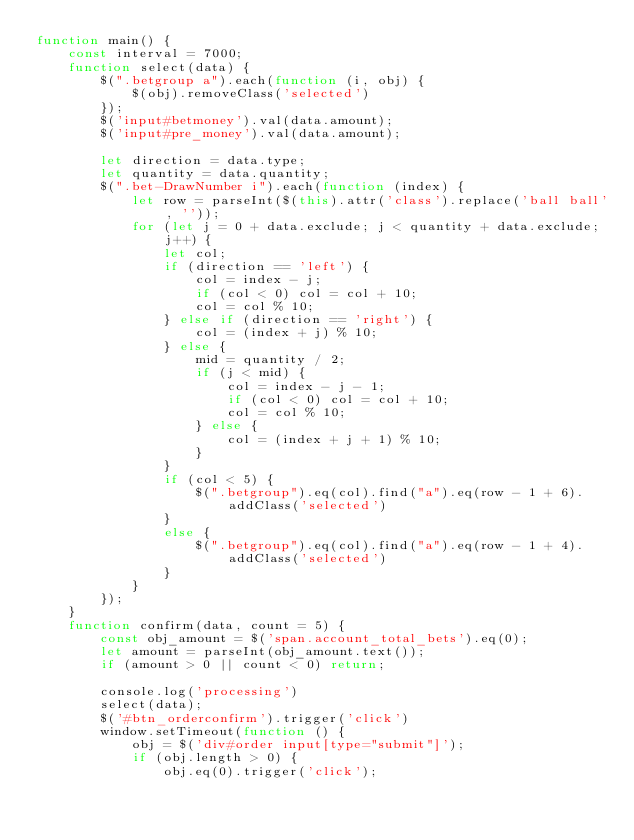Convert code to text. <code><loc_0><loc_0><loc_500><loc_500><_JavaScript_>function main() {
    const interval = 7000;
    function select(data) {
        $(".betgroup a").each(function (i, obj) {
            $(obj).removeClass('selected')
        });
        $('input#betmoney').val(data.amount);
        $('input#pre_money').val(data.amount);

        let direction = data.type;
        let quantity = data.quantity;
        $(".bet-DrawNumber i").each(function (index) {
            let row = parseInt($(this).attr('class').replace('ball ball', ''));
            for (let j = 0 + data.exclude; j < quantity + data.exclude; j++) {
                let col;
                if (direction == 'left') {
                    col = index - j;
                    if (col < 0) col = col + 10;
                    col = col % 10;
                } else if (direction == 'right') {
                    col = (index + j) % 10;
                } else {
                    mid = quantity / 2;
                    if (j < mid) {
                        col = index - j - 1;
                        if (col < 0) col = col + 10;
                        col = col % 10;
                    } else {
                        col = (index + j + 1) % 10;
                    }
                }
                if (col < 5) {
                    $(".betgroup").eq(col).find("a").eq(row - 1 + 6).addClass('selected')
                }
                else {
                    $(".betgroup").eq(col).find("a").eq(row - 1 + 4).addClass('selected')
                }
            }
        });
    }
    function confirm(data, count = 5) {
        const obj_amount = $('span.account_total_bets').eq(0);
        let amount = parseInt(obj_amount.text());
        if (amount > 0 || count < 0) return;

        console.log('processing')
        select(data);
        $('#btn_orderconfirm').trigger('click')
        window.setTimeout(function () {
            obj = $('div#order input[type="submit"]');
            if (obj.length > 0) {
                obj.eq(0).trigger('click');</code> 